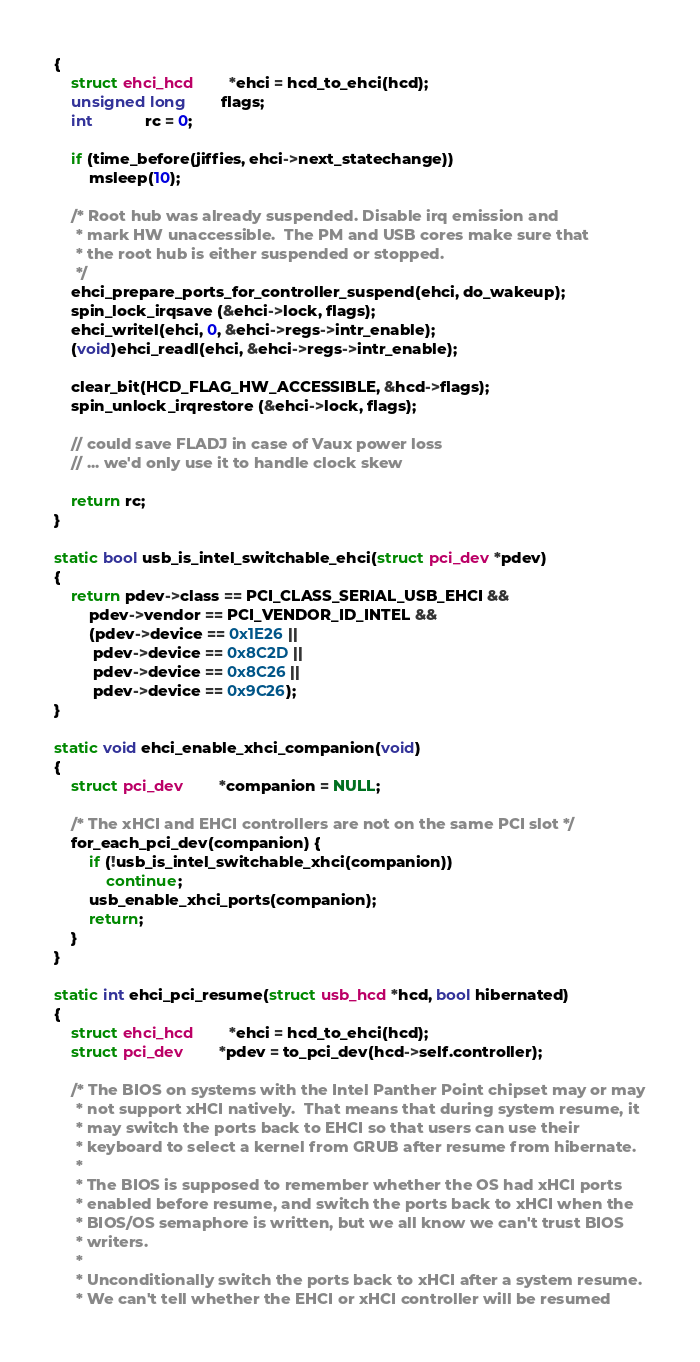<code> <loc_0><loc_0><loc_500><loc_500><_C_>{
	struct ehci_hcd		*ehci = hcd_to_ehci(hcd);
	unsigned long		flags;
	int			rc = 0;

	if (time_before(jiffies, ehci->next_statechange))
		msleep(10);

	/* Root hub was already suspended. Disable irq emission and
	 * mark HW unaccessible.  The PM and USB cores make sure that
	 * the root hub is either suspended or stopped.
	 */
	ehci_prepare_ports_for_controller_suspend(ehci, do_wakeup);
	spin_lock_irqsave (&ehci->lock, flags);
	ehci_writel(ehci, 0, &ehci->regs->intr_enable);
	(void)ehci_readl(ehci, &ehci->regs->intr_enable);

	clear_bit(HCD_FLAG_HW_ACCESSIBLE, &hcd->flags);
	spin_unlock_irqrestore (&ehci->lock, flags);

	// could save FLADJ in case of Vaux power loss
	// ... we'd only use it to handle clock skew

	return rc;
}

static bool usb_is_intel_switchable_ehci(struct pci_dev *pdev)
{
	return pdev->class == PCI_CLASS_SERIAL_USB_EHCI &&
		pdev->vendor == PCI_VENDOR_ID_INTEL &&
		(pdev->device == 0x1E26 ||
		 pdev->device == 0x8C2D ||
		 pdev->device == 0x8C26 ||
		 pdev->device == 0x9C26);
}

static void ehci_enable_xhci_companion(void)
{
	struct pci_dev		*companion = NULL;

	/* The xHCI and EHCI controllers are not on the same PCI slot */
	for_each_pci_dev(companion) {
		if (!usb_is_intel_switchable_xhci(companion))
			continue;
		usb_enable_xhci_ports(companion);
		return;
	}
}

static int ehci_pci_resume(struct usb_hcd *hcd, bool hibernated)
{
	struct ehci_hcd		*ehci = hcd_to_ehci(hcd);
	struct pci_dev		*pdev = to_pci_dev(hcd->self.controller);

	/* The BIOS on systems with the Intel Panther Point chipset may or may
	 * not support xHCI natively.  That means that during system resume, it
	 * may switch the ports back to EHCI so that users can use their
	 * keyboard to select a kernel from GRUB after resume from hibernate.
	 *
	 * The BIOS is supposed to remember whether the OS had xHCI ports
	 * enabled before resume, and switch the ports back to xHCI when the
	 * BIOS/OS semaphore is written, but we all know we can't trust BIOS
	 * writers.
	 *
	 * Unconditionally switch the ports back to xHCI after a system resume.
	 * We can't tell whether the EHCI or xHCI controller will be resumed</code> 